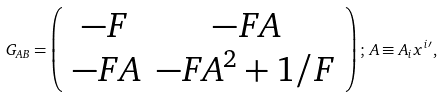Convert formula to latex. <formula><loc_0><loc_0><loc_500><loc_500>G _ { A B } = \left ( \begin{array} { c c } - F & - F A \\ - F A & - F A ^ { 2 } + 1 / F \end{array} \right ) ; \, A \equiv A _ { i } x ^ { i } { ^ { \prime } } ,</formula> 